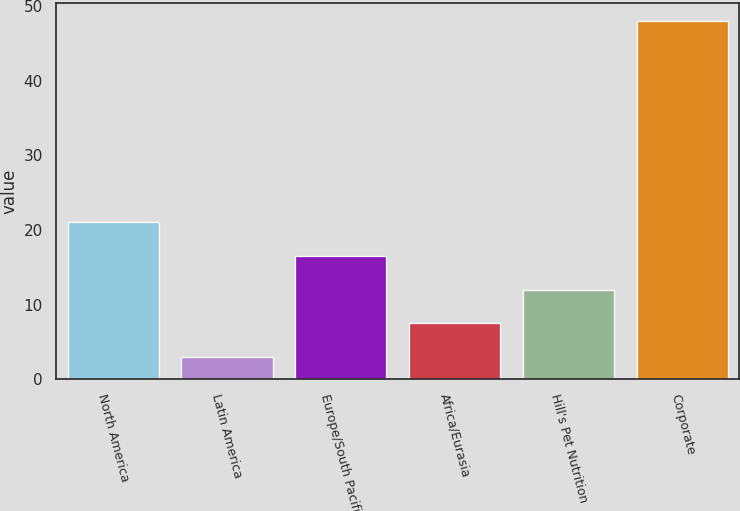<chart> <loc_0><loc_0><loc_500><loc_500><bar_chart><fcel>North America<fcel>Latin America<fcel>Europe/South Pacific<fcel>Africa/Eurasia<fcel>Hill's Pet Nutrition<fcel>Corporate<nl><fcel>21<fcel>3<fcel>16.5<fcel>7.5<fcel>12<fcel>48<nl></chart> 